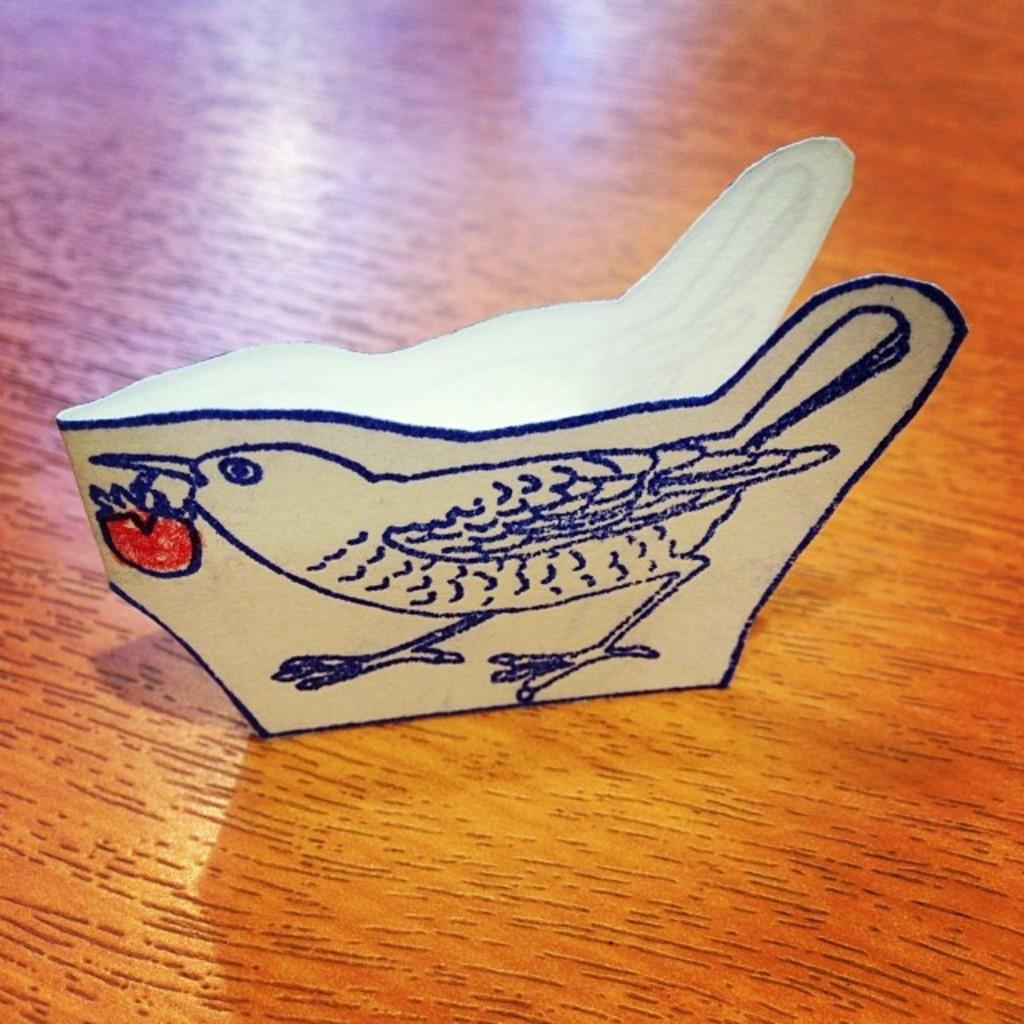What type of artwork is shown in the image? The image is a drawing. What animal is depicted in the drawing? The drawing depicts a sparrow. What is the sparrow holding in its beak? The sparrow is holding a fruit in its beak. What color is the fruit being held by the sparrow? The fruit is in red color. Is there a maid cleaning the marble floor in the image? There is no maid or marble floor present in the image; it features a drawing of a sparrow holding a red fruit. 